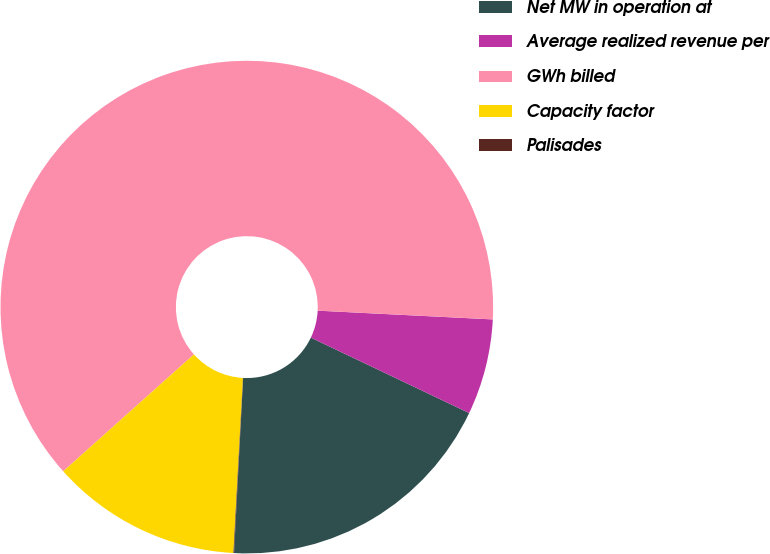<chart> <loc_0><loc_0><loc_500><loc_500><pie_chart><fcel>Net MW in operation at<fcel>Average realized revenue per<fcel>GWh billed<fcel>Capacity factor<fcel>Palisades<nl><fcel>18.75%<fcel>6.28%<fcel>62.41%<fcel>12.52%<fcel>0.04%<nl></chart> 